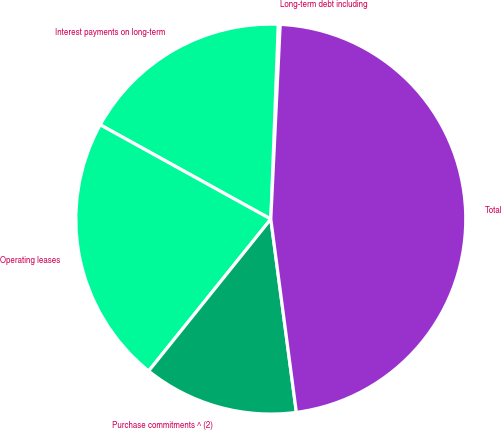<chart> <loc_0><loc_0><loc_500><loc_500><pie_chart><fcel>Long-term debt including<fcel>Interest payments on long-term<fcel>Operating leases<fcel>Purchase commitments ^ (2)<fcel>Total<nl><fcel>0.16%<fcel>17.57%<fcel>22.26%<fcel>12.87%<fcel>47.14%<nl></chart> 